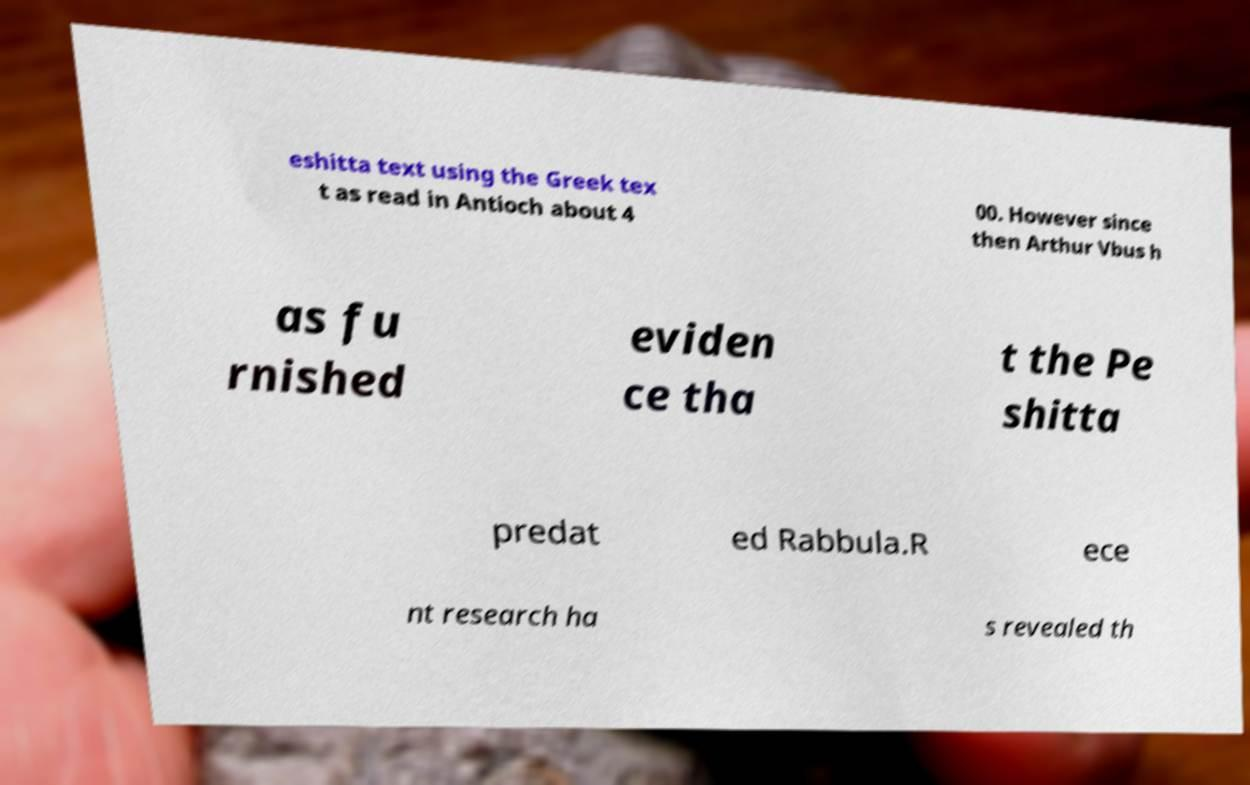Can you accurately transcribe the text from the provided image for me? eshitta text using the Greek tex t as read in Antioch about 4 00. However since then Arthur Vbus h as fu rnished eviden ce tha t the Pe shitta predat ed Rabbula.R ece nt research ha s revealed th 